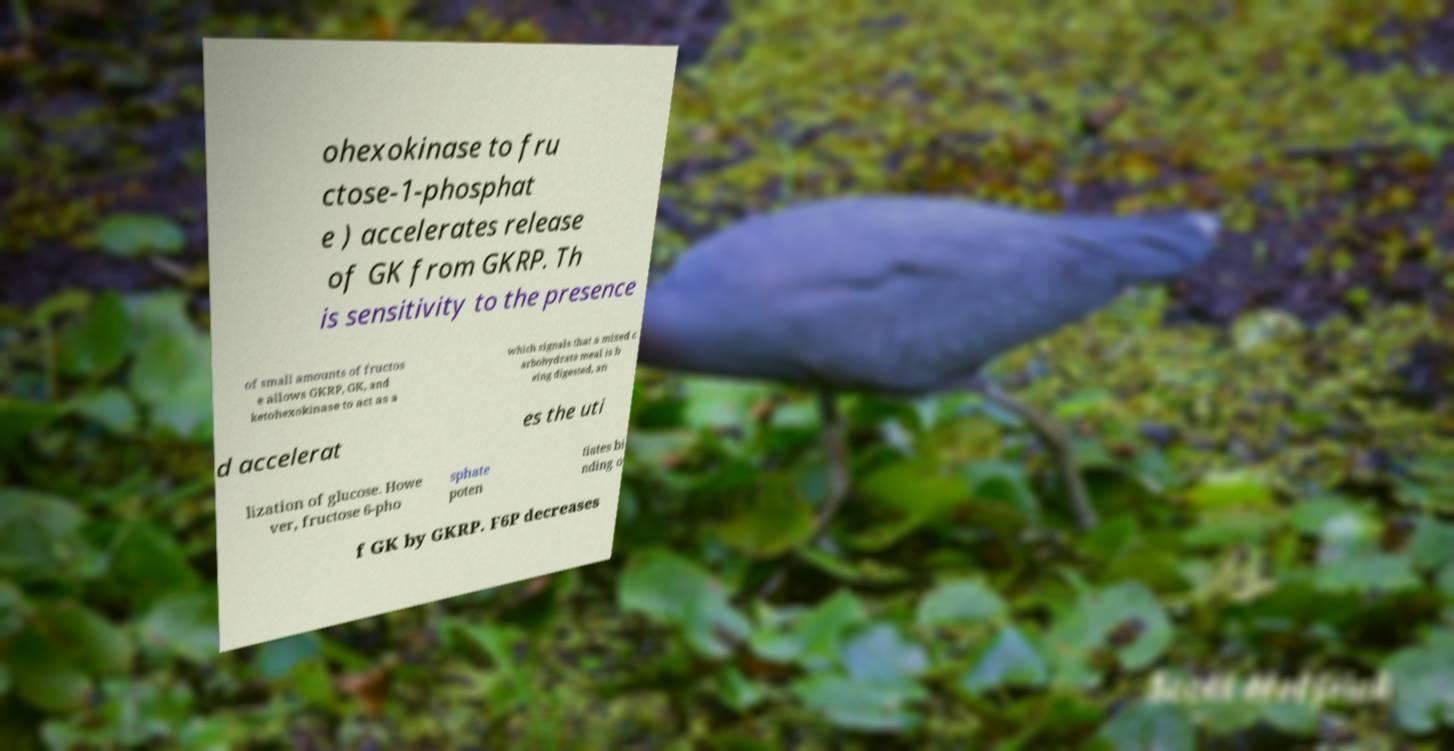What messages or text are displayed in this image? I need them in a readable, typed format. ohexokinase to fru ctose-1-phosphat e ) accelerates release of GK from GKRP. Th is sensitivity to the presence of small amounts of fructos e allows GKRP, GK, and ketohexokinase to act as a which signals that a mixed c arbohydrate meal is b eing digested, an d accelerat es the uti lization of glucose. Howe ver, fructose 6-pho sphate poten tiates bi nding o f GK by GKRP. F6P decreases 